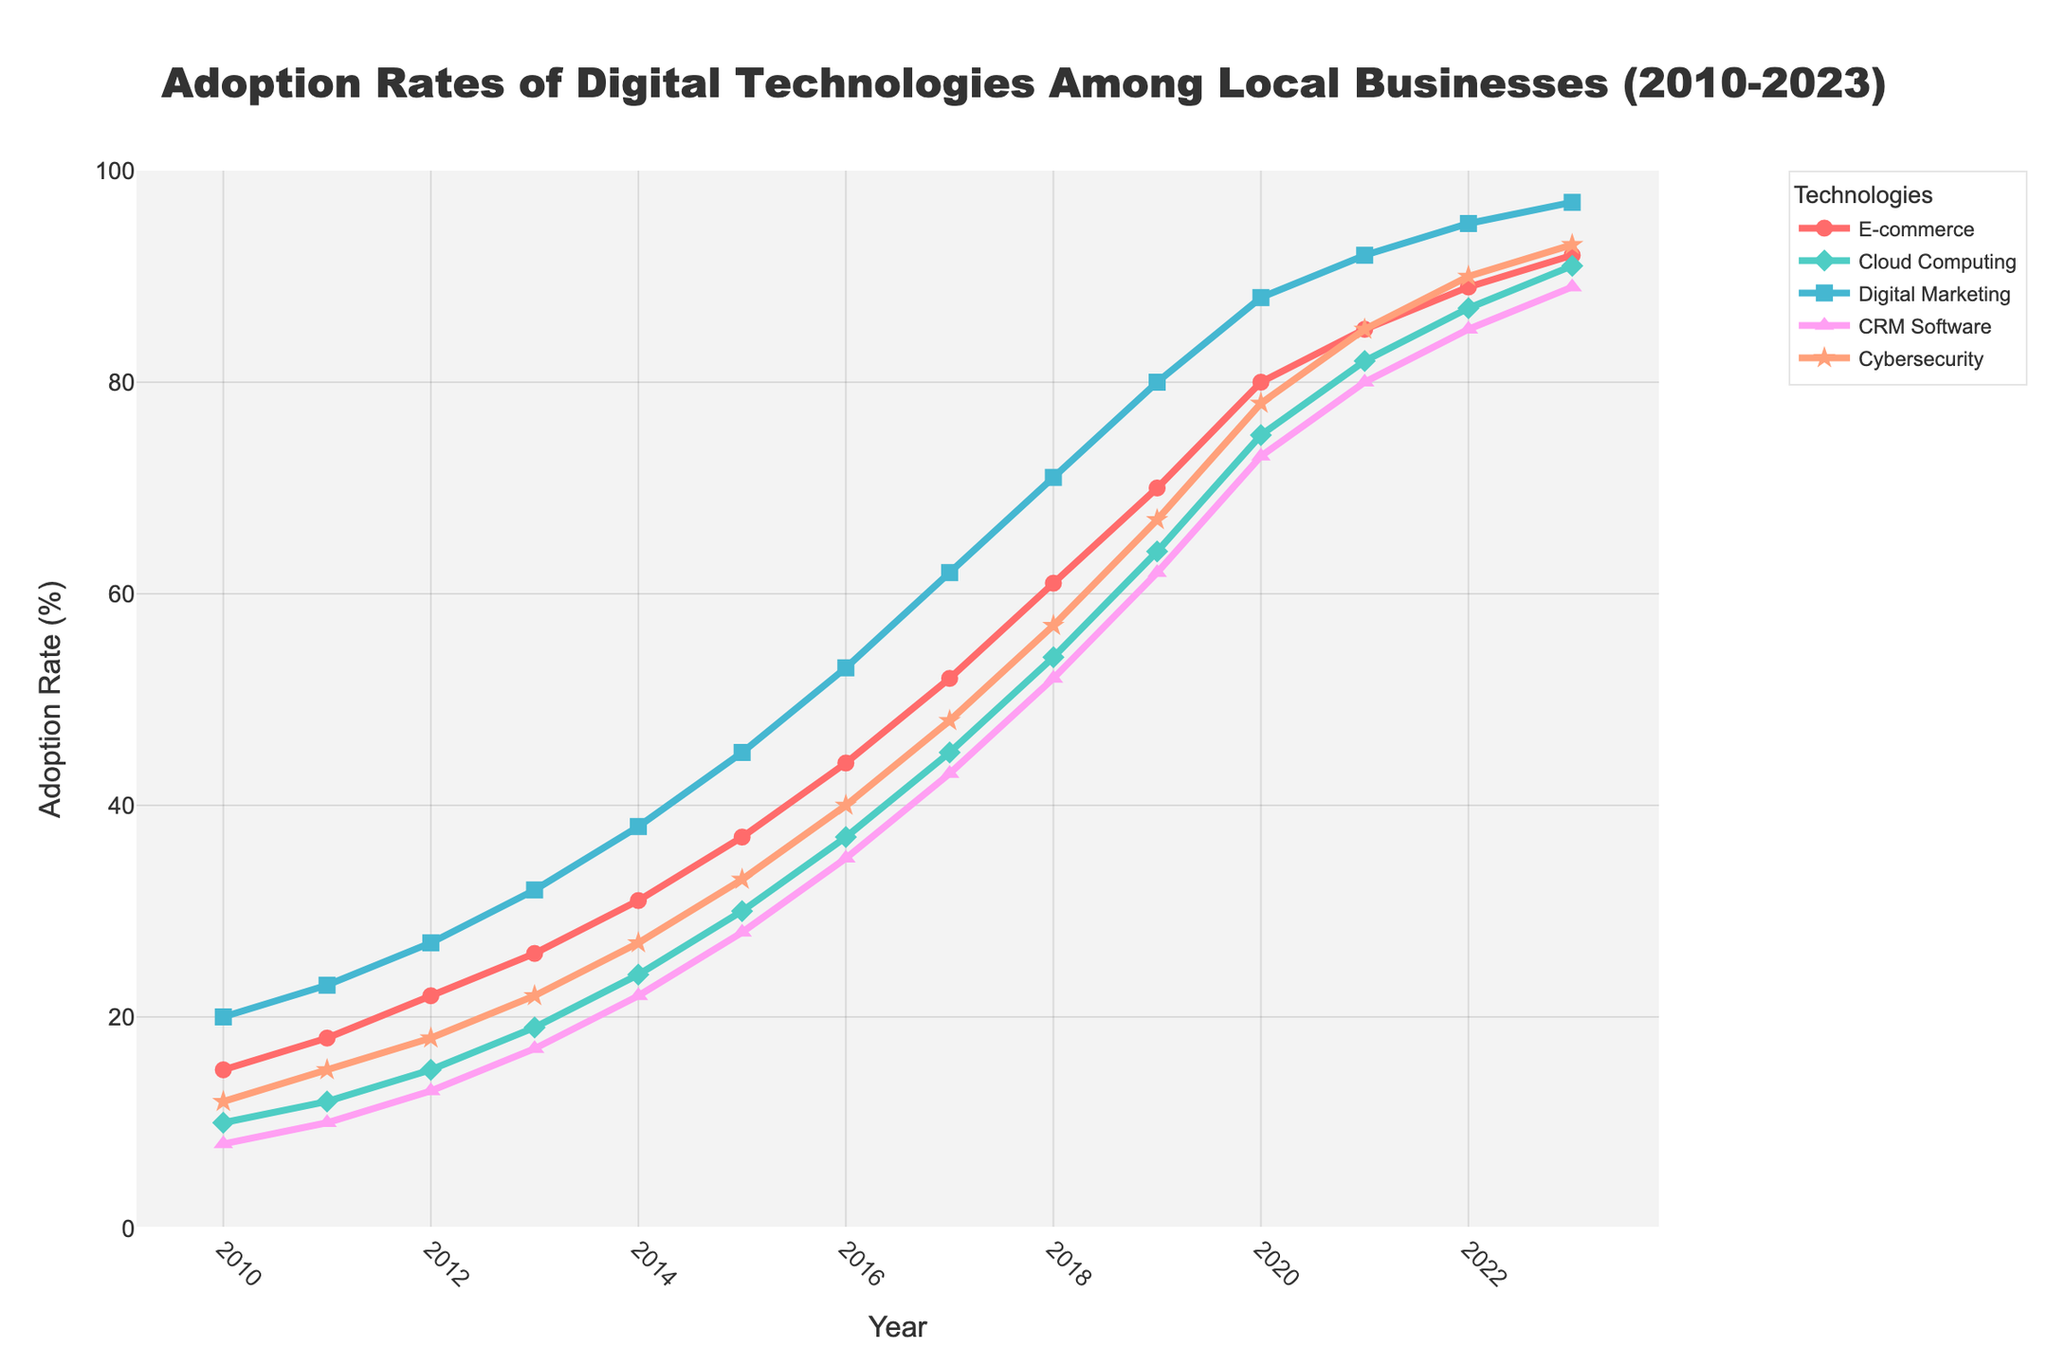What's the overall trend of E-commerce adoption from 2010 to 2023? The E-commerce adoption rate starts at 15% in 2010 and steadily increases to 92% in 2023. This indicates a significant upward trend in the adoption of E-commerce over the 13-year period.
Answer: Upward trend Which technology has seen the highest percentage increase from 2010 to 2023? Cybersecurity Measures went from 12% in 2010 to 93% in 2023, which corresponds to an 81 percentage point increase, higher than any other technology.
Answer: Cybersecurity Measures Between 2015 and 2020, which technology experienced the most rapid growth in adoption rate? Digital Marketing grew from 45% in 2015 to 88% in 2020. This is a 43 percentage point increase, which is the highest among all technologies in this period.
Answer: Digital Marketing In 2022, which technology has the lowest adoption rate and what is the rate? Looking at the figure, the lowest adoption rate in 2022 is for E-commerce Adoption at 89%.
Answer: E-commerce Adoption, 89% Compare the adoption rates of Cloud Computing and CRM Software in 2020. Which is higher and by how much? In 2020, the adoption rate of Cloud Computing is 75%, and CRM Software is 73%. Cloud Computing is higher by 2 percentage points.
Answer: Cloud Computing, 2% What is the median adoption rate of Cybersecurity Measures over the years shown? To find the median, order the adoption rates: 12, 15, 18, 22, 27, 33, 40, 48, 57, 67, 78, 85, 90, 93. The middle values are 33 and 40, so the median is (33+40)/2 = 36.5.
Answer: 36.5 Which year shows a crossover where Cloud Computing adoption rate surpasses that of Digital Marketing? Cloud Computing surpasses Digital Marketing between 2019 (Cloud Computing at 64%, Digital at 80%) and 2020 (Cloud Computing at 75%, Digital at 88%). No exact crossover can be pinpointed within the yearly data provided.
Answer: 2019-2020 How much did the E-commerce adoption rate grow between 2017 and 2022? E-commerce adoption was 52% in 2017 and 89% in 2022. The growth is 89% - 52% = 37 percentage points.
Answer: 37 percentage points Which technology had an adoption rate closest to 50% in any given year, and what year was it? CRM Software had an adoption rate of 52% in 2018, which is the closest to 50% among all data points.
Answer: CRM Software, 2018 Compare the adoption rates of E-commerce and Digital Marketing in 2023. In 2023, E-commerce adoption is 92%, and Digital Marketing is 97%. Digital Marketing is 5 percentage points higher than E-commerce.
Answer: Digital Marketing, 5% 